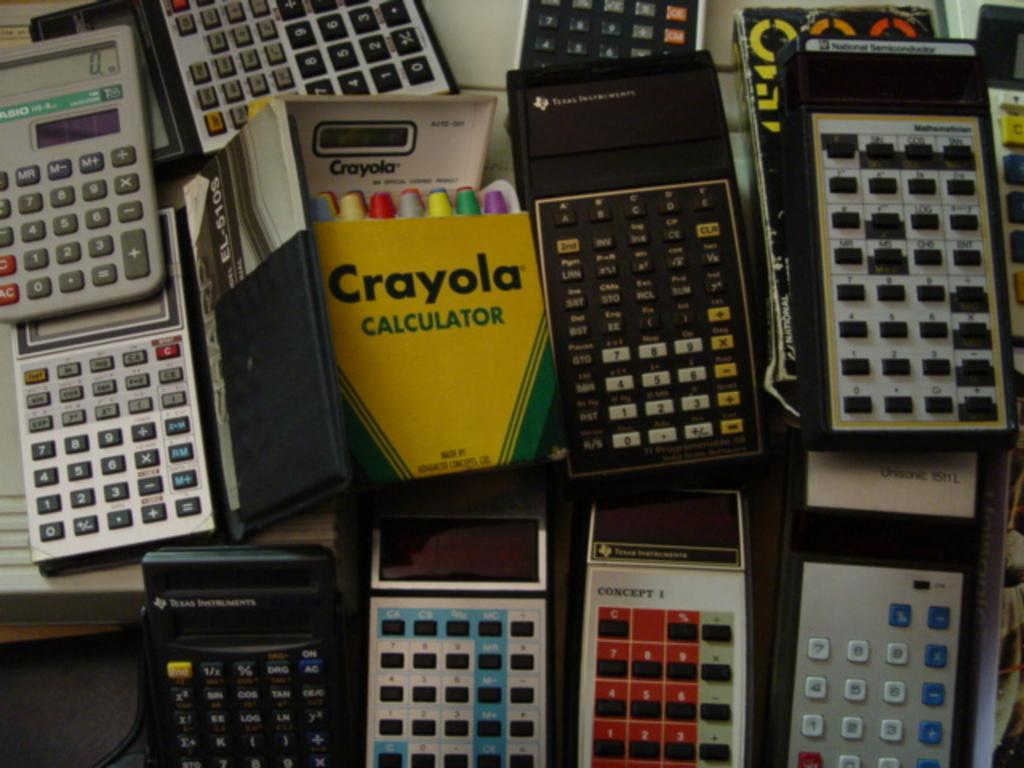Provide a one-sentence caption for the provided image. A fun Crayola Calculator sits in the middle of several old Texas Instrument calculators. 